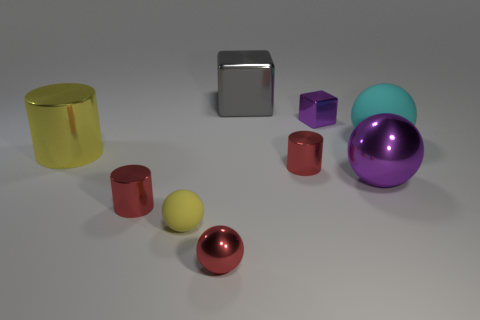Subtract all brown balls. Subtract all blue cylinders. How many balls are left? 4 Add 1 big yellow cylinders. How many objects exist? 10 Subtract all blocks. How many objects are left? 7 Subtract all big cylinders. Subtract all small red metal balls. How many objects are left? 7 Add 9 large cyan rubber things. How many large cyan rubber things are left? 10 Add 2 shiny things. How many shiny things exist? 9 Subtract 1 red spheres. How many objects are left? 8 